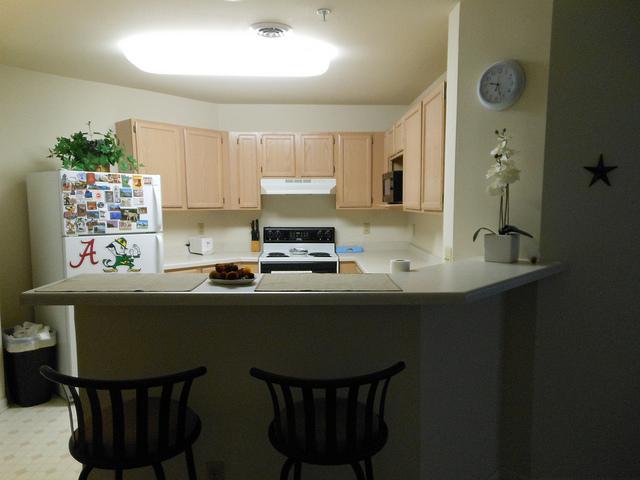How many seats are there?
Be succinct. 2. What sports teams are represented on the fridge?
Write a very short answer. Notre dame. Is there a clock on the wall?
Be succinct. Yes. 